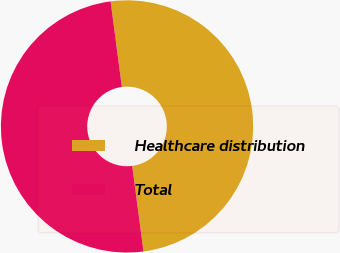Convert chart to OTSL. <chart><loc_0><loc_0><loc_500><loc_500><pie_chart><fcel>Healthcare distribution<fcel>Total<nl><fcel>50.0%<fcel>50.0%<nl></chart> 